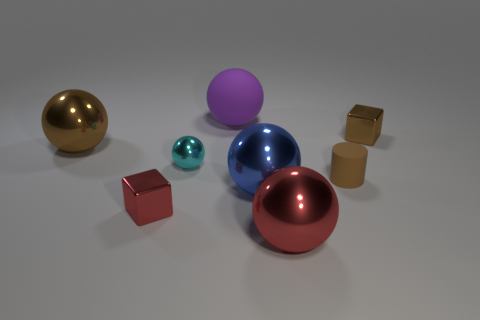Subtract all big purple balls. How many balls are left? 4 Subtract all blue spheres. How many spheres are left? 4 Subtract all spheres. How many objects are left? 3 Add 2 tiny brown metallic objects. How many objects exist? 10 Subtract all cyan spheres. How many brown cubes are left? 1 Subtract all large blue metallic objects. Subtract all purple cubes. How many objects are left? 7 Add 2 small brown cubes. How many small brown cubes are left? 3 Add 7 brown cylinders. How many brown cylinders exist? 8 Subtract 0 red cylinders. How many objects are left? 8 Subtract 1 cylinders. How many cylinders are left? 0 